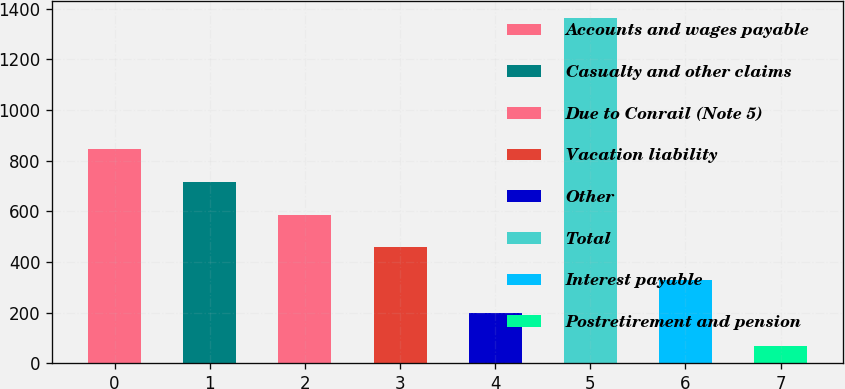Convert chart to OTSL. <chart><loc_0><loc_0><loc_500><loc_500><bar_chart><fcel>Accounts and wages payable<fcel>Casualty and other claims<fcel>Due to Conrail (Note 5)<fcel>Vacation liability<fcel>Other<fcel>Total<fcel>Interest payable<fcel>Postretirement and pension<nl><fcel>845.2<fcel>716<fcel>586.8<fcel>457.6<fcel>199.2<fcel>1362<fcel>328.4<fcel>70<nl></chart> 